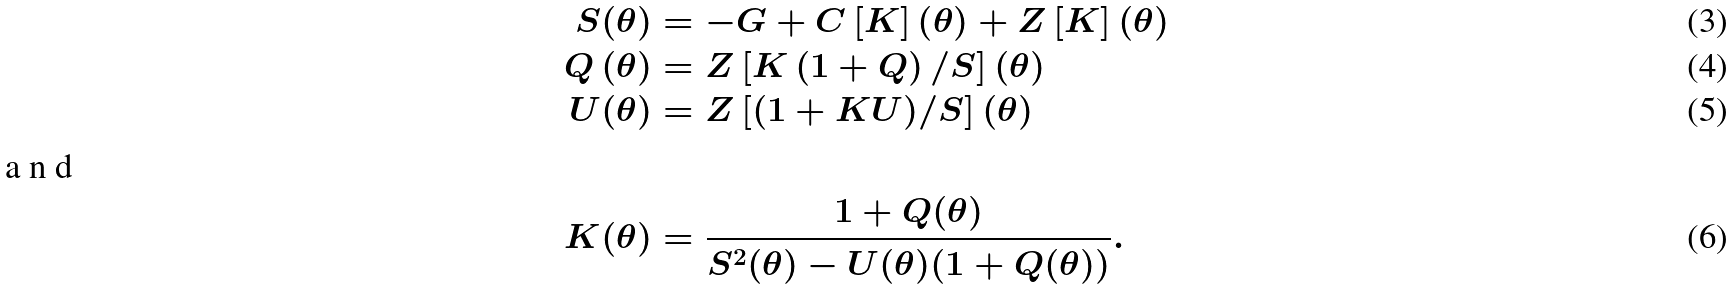Convert formula to latex. <formula><loc_0><loc_0><loc_500><loc_500>S ( \theta ) & = - G + C \left [ K \right ] \left ( \theta \right ) + Z \left [ K \right ] \left ( \theta \right ) \\ Q \left ( \theta \right ) & = Z \left [ K \left ( 1 + Q \right ) / S \right ] \left ( \theta \right ) \\ U ( \theta ) & = Z \left [ ( 1 + K U ) / S \right ] ( \theta ) \\ \intertext { a n d } K ( \theta ) & = \frac { 1 + Q ( \theta ) } { S ^ { 2 } ( \theta ) - U ( \theta ) ( 1 + Q ( \theta ) ) } .</formula> 